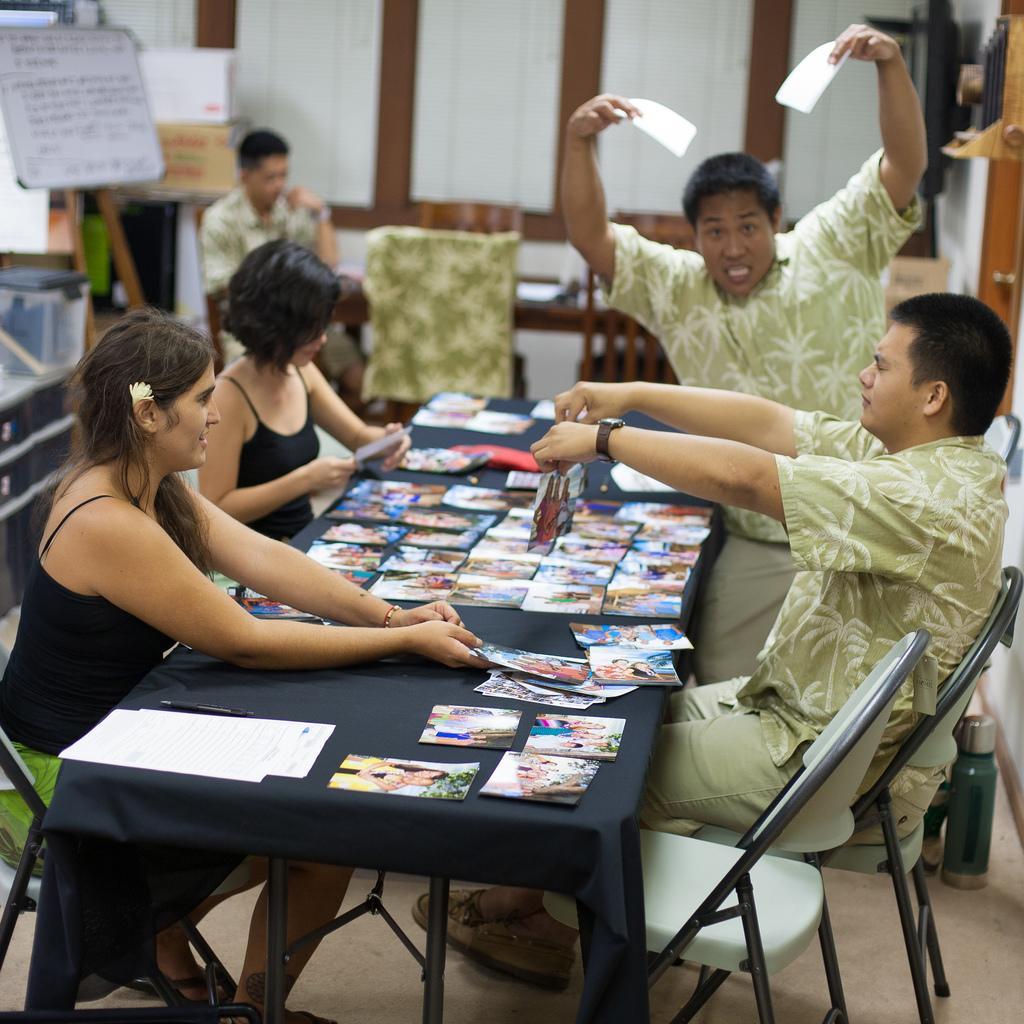Can you describe this image briefly? In this image we can see this people sitting on chairs near the table. There are many photographs on the table. In the background we can see a person sitting near the table and a board. 